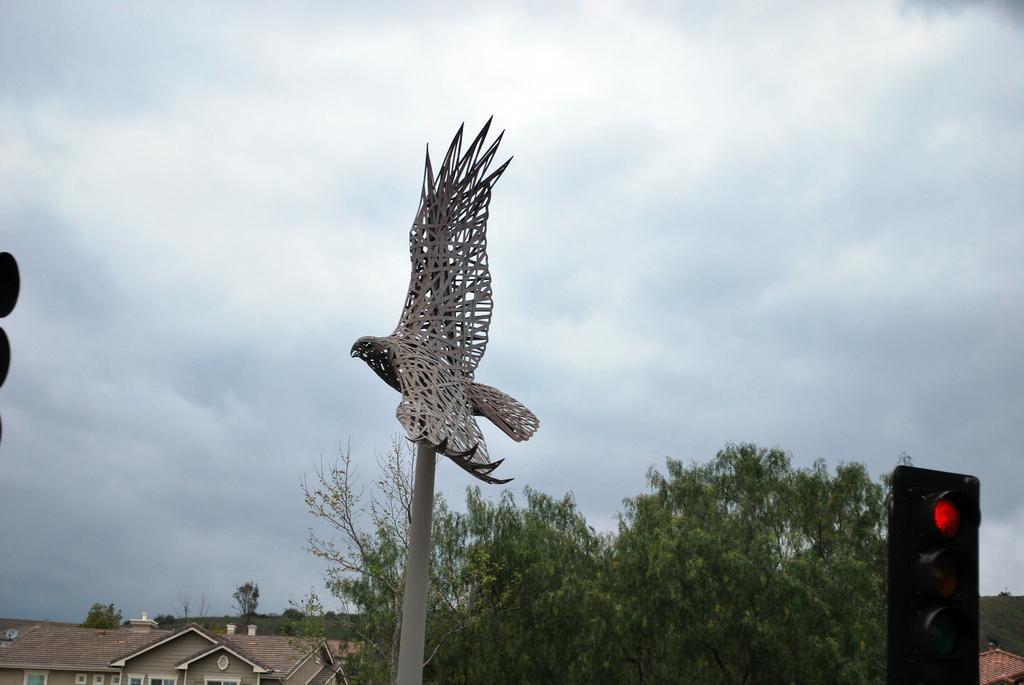Can you describe this image briefly? This image consists of many trees. On the left, there are houses. On the right, we can see a signal light. In the middle, there is an artificial bird on a pole. In the background, there are clouds in the sky. 